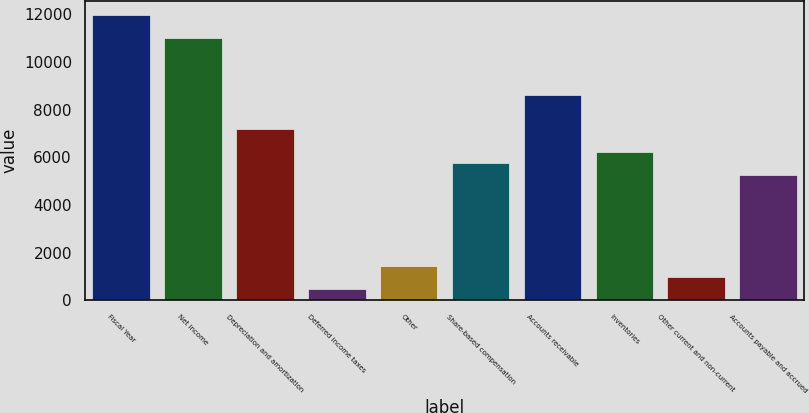Convert chart to OTSL. <chart><loc_0><loc_0><loc_500><loc_500><bar_chart><fcel>Fiscal Year<fcel>Net income<fcel>Depreciation and amortization<fcel>Deferred income taxes<fcel>Other<fcel>Share-based compensation<fcel>Accounts receivable<fcel>Inventories<fcel>Other current and non-current<fcel>Accounts payable and accrued<nl><fcel>11968.5<fcel>11012.3<fcel>7187.5<fcel>494.1<fcel>1450.3<fcel>5753.2<fcel>8621.8<fcel>6231.3<fcel>972.2<fcel>5275.1<nl></chart> 